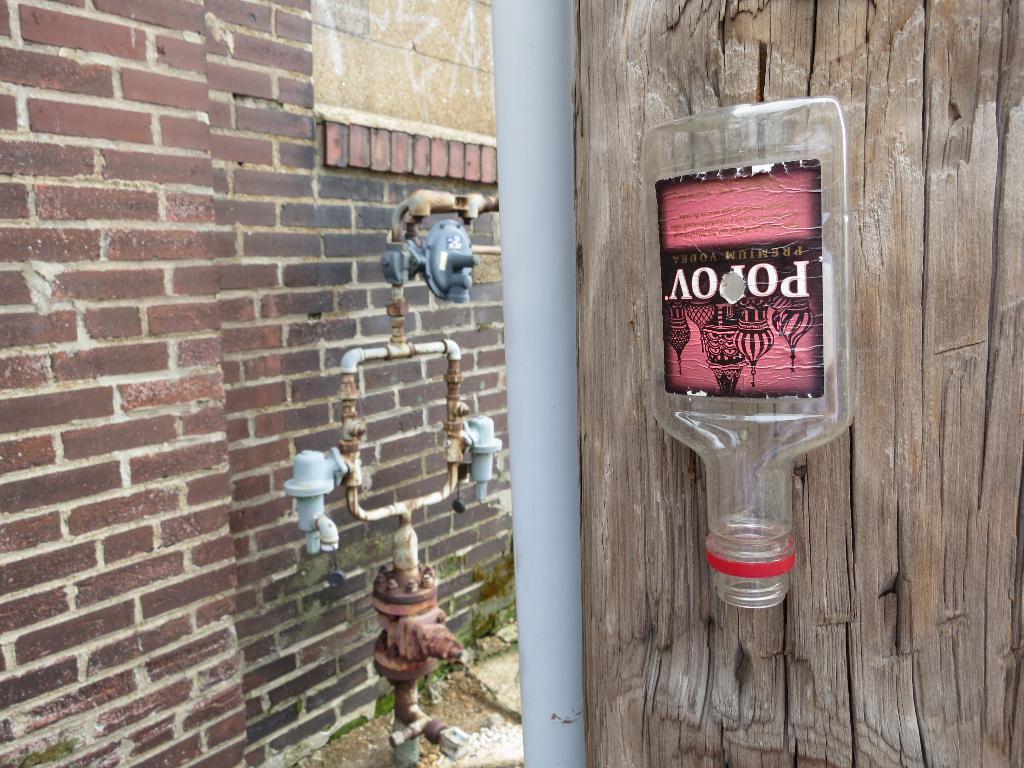How would you summarize this image in a sentence or two? In this image, we can see a bottle and pile, some machine in the middle. On right side, we can see wooden. Left side, there is a brick wall. 